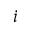<formula> <loc_0><loc_0><loc_500><loc_500>i</formula> 